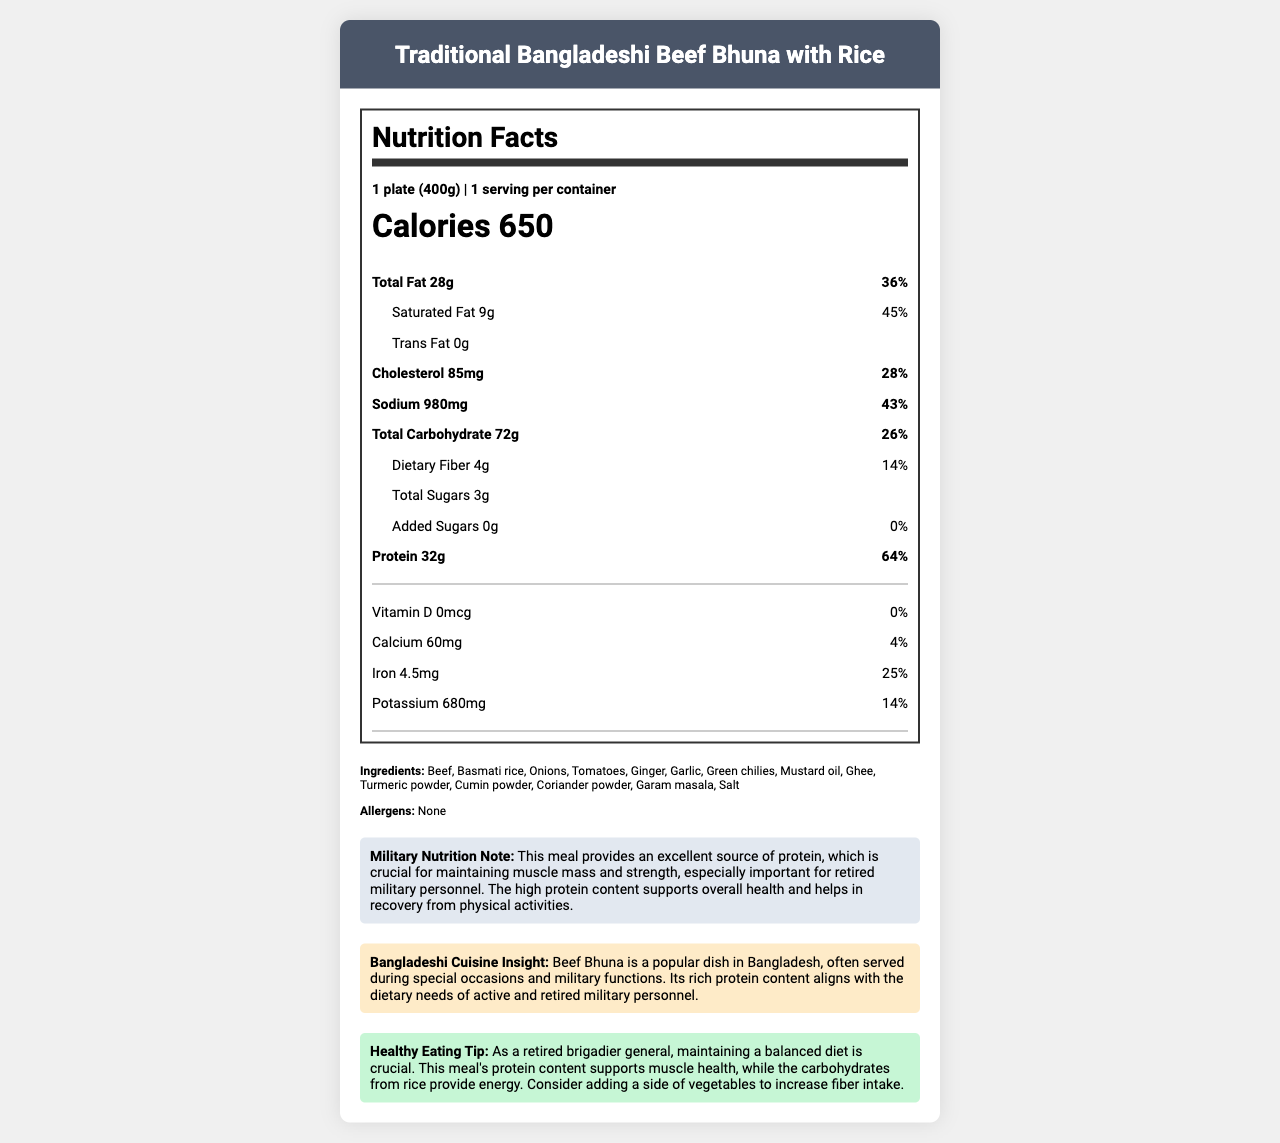how much protein is in one serving of Traditional Bangladeshi Beef Bhuna with Rice? The document states that one serving contains 32 grams of protein.
Answer: 32g what is the serving size of the meal? The document lists the serving size as 1 plate, which equals 400 grams.
Answer: 1 plate (400g) how many calories are there per serving? The document specifies that there are 650 calories per serving.
Answer: 650 what is the daily value percentage of protein in this meal? The document mentions that the protein content provides 64% of the daily value.
Answer: 64% what are the main ingredients in the Traditional Bangladeshi Beef Bhuna with Rice? The document lists these as the main ingredients.
Answer: Beef, Basmati rice, Onions, Tomatoes, Ginger, Garlic, Green chilies, Mustard oil, Ghee, Turmeric powder, Cumin powder, Coriander powder, Garam masala, Salt what does the meal’s Military Nutrition Note emphasize? The Military Nutrition Note emphasizes that the meal’s high protein content is crucial for maintaining muscle mass and strength and helps in recovery from physical activities, especially important for retired military personnel.
Answer: Protein content supporting muscle mass and recovery what is the percentage of daily value for iron in this meal? The document states that the meal provides 25% of the daily value for iron.
Answer: 25% what nutrient has the highest daily value percentage in the Traditional Bangladeshi Beef Bhuna with Rice? The document indicates that protein has the highest daily value percentage at 64%.
Answer: Protein at 64% how does the document suggest maintaining a balanced diet for retired brigadier generals? The Healthy Eating Tip suggests maintaining a balanced diet by consuming high-protein meals and adding a side of vegetables to increase fiber intake.
Answer: By consuming meals with high protein content and adding vegetables to increase fiber intake which nutrient does the Traditional Bangladeshi Beef Bhuna with Rice contain in the amount of 72g? The document states that the total carbohydrate content is 72 grams.
Answer: Total Carbohydrate how much sodium does this meal contain? The document specifies that the sodium content is 980 milligrams.
Answer: 980mg what is the daily value percentage for saturated fat in this meal? The document lists the daily value percentage for saturated fat as 45%.
Answer: 45% how much dietary fiber is there in this meal? A. 1g B. 3g C. 4g D. 5g The document states the dietary fiber content as 4 grams.
Answer: C. 4g how much calcium does this meal provide? A. 60mg B. 100mg C. 120mg D. 150mg The document mentions that the meal provides 60 milligrams of calcium.
Answer: A. 60mg does this meal contain any allergens? The document specifies that there are no allergens in this meal.
Answer: No describe the main idea of the document. The document offers detailed nutritional information, including serving size, calorie count, and daily value percentages for various nutrients, and highlights the benefits of high protein intake. It also includes cultural insights and dietary recommendations specifically tailored for the needs of retired brigadier generals.
Answer: This document provides comprehensive nutrition facts for a Traditional Bangladeshi Beef Bhuna with Rice meal, emphasizing its high protein content, which supports muscle health and recovery for retired military personnel. It also provides insights into Bangladeshi cuisine and healthy eating tips for maintaining a balanced diet. what is the exact percentage of daily value for potassium in this meal? The document lists the daily value percentage for several nutrients but does not mention the exact percentage for potassium.
Answer: Not enough information describe what kinds of fats are present in this meal and their respective amounts. The document provides information on three types of fats: 28 grams of Total Fat, 9 grams of Saturated Fat, and 0 grams of Trans Fat.
Answer: Total Fat: 28g, Saturated Fat: 9g, Trans Fat: 0g 